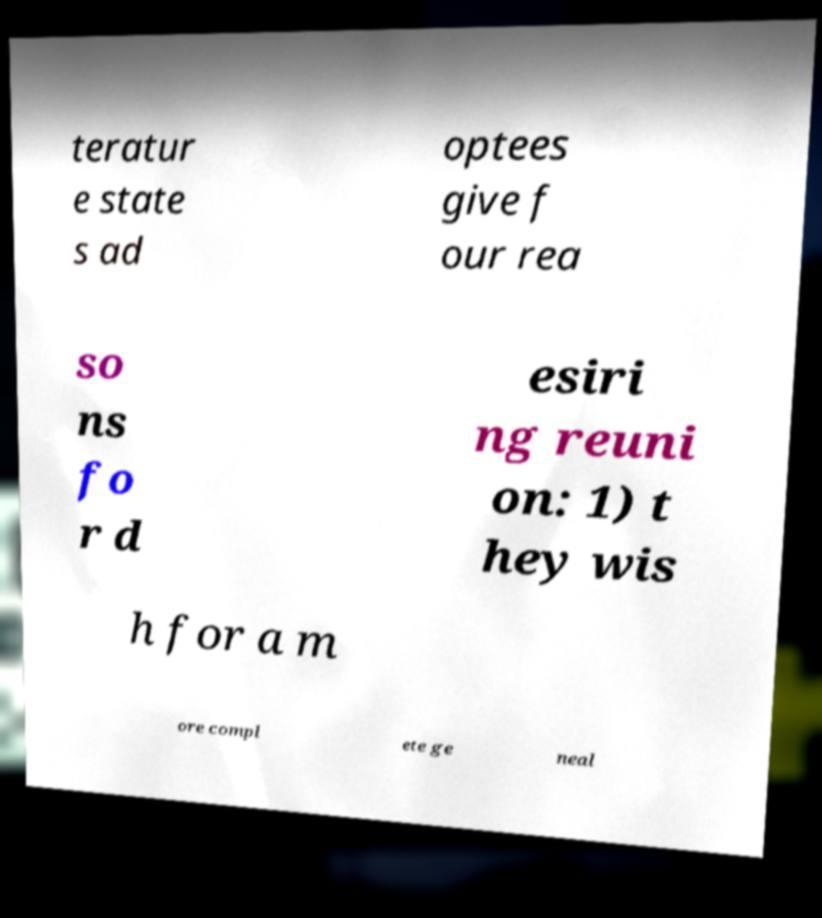Please identify and transcribe the text found in this image. teratur e state s ad optees give f our rea so ns fo r d esiri ng reuni on: 1) t hey wis h for a m ore compl ete ge neal 